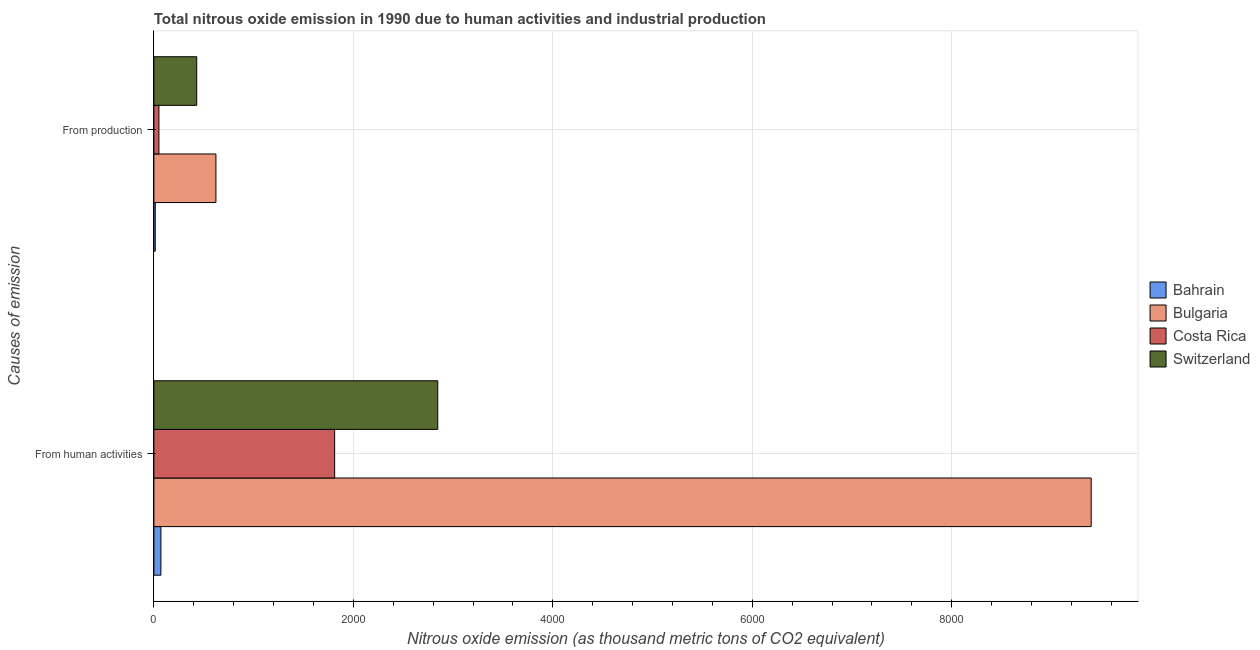Are the number of bars per tick equal to the number of legend labels?
Ensure brevity in your answer.  Yes. How many bars are there on the 1st tick from the bottom?
Your response must be concise. 4. What is the label of the 2nd group of bars from the top?
Offer a terse response. From human activities. What is the amount of emissions from human activities in Bulgaria?
Keep it short and to the point. 9398. Across all countries, what is the maximum amount of emissions generated from industries?
Your answer should be very brief. 622. Across all countries, what is the minimum amount of emissions from human activities?
Provide a short and direct response. 70.2. In which country was the amount of emissions generated from industries maximum?
Your answer should be compact. Bulgaria. In which country was the amount of emissions generated from industries minimum?
Offer a terse response. Bahrain. What is the total amount of emissions generated from industries in the graph?
Your response must be concise. 1115.8. What is the difference between the amount of emissions generated from industries in Switzerland and that in Costa Rica?
Your answer should be very brief. 379.1. What is the difference between the amount of emissions generated from industries in Switzerland and the amount of emissions from human activities in Bulgaria?
Ensure brevity in your answer.  -8968.4. What is the average amount of emissions generated from industries per country?
Keep it short and to the point. 278.95. What is the difference between the amount of emissions generated from industries and amount of emissions from human activities in Bulgaria?
Offer a terse response. -8776. What is the ratio of the amount of emissions from human activities in Bahrain to that in Bulgaria?
Ensure brevity in your answer.  0.01. How many bars are there?
Provide a succinct answer. 8. Are all the bars in the graph horizontal?
Keep it short and to the point. Yes. How many countries are there in the graph?
Make the answer very short. 4. What is the difference between two consecutive major ticks on the X-axis?
Make the answer very short. 2000. Are the values on the major ticks of X-axis written in scientific E-notation?
Give a very brief answer. No. Where does the legend appear in the graph?
Make the answer very short. Center right. How many legend labels are there?
Your answer should be compact. 4. What is the title of the graph?
Offer a very short reply. Total nitrous oxide emission in 1990 due to human activities and industrial production. What is the label or title of the X-axis?
Make the answer very short. Nitrous oxide emission (as thousand metric tons of CO2 equivalent). What is the label or title of the Y-axis?
Provide a succinct answer. Causes of emission. What is the Nitrous oxide emission (as thousand metric tons of CO2 equivalent) of Bahrain in From human activities?
Ensure brevity in your answer.  70.2. What is the Nitrous oxide emission (as thousand metric tons of CO2 equivalent) of Bulgaria in From human activities?
Provide a short and direct response. 9398. What is the Nitrous oxide emission (as thousand metric tons of CO2 equivalent) in Costa Rica in From human activities?
Make the answer very short. 1812.5. What is the Nitrous oxide emission (as thousand metric tons of CO2 equivalent) of Switzerland in From human activities?
Offer a very short reply. 2846.4. What is the Nitrous oxide emission (as thousand metric tons of CO2 equivalent) of Bahrain in From production?
Ensure brevity in your answer.  13.7. What is the Nitrous oxide emission (as thousand metric tons of CO2 equivalent) in Bulgaria in From production?
Give a very brief answer. 622. What is the Nitrous oxide emission (as thousand metric tons of CO2 equivalent) of Costa Rica in From production?
Make the answer very short. 50.5. What is the Nitrous oxide emission (as thousand metric tons of CO2 equivalent) of Switzerland in From production?
Give a very brief answer. 429.6. Across all Causes of emission, what is the maximum Nitrous oxide emission (as thousand metric tons of CO2 equivalent) in Bahrain?
Provide a short and direct response. 70.2. Across all Causes of emission, what is the maximum Nitrous oxide emission (as thousand metric tons of CO2 equivalent) of Bulgaria?
Your answer should be very brief. 9398. Across all Causes of emission, what is the maximum Nitrous oxide emission (as thousand metric tons of CO2 equivalent) in Costa Rica?
Provide a short and direct response. 1812.5. Across all Causes of emission, what is the maximum Nitrous oxide emission (as thousand metric tons of CO2 equivalent) in Switzerland?
Make the answer very short. 2846.4. Across all Causes of emission, what is the minimum Nitrous oxide emission (as thousand metric tons of CO2 equivalent) in Bulgaria?
Your answer should be very brief. 622. Across all Causes of emission, what is the minimum Nitrous oxide emission (as thousand metric tons of CO2 equivalent) of Costa Rica?
Ensure brevity in your answer.  50.5. Across all Causes of emission, what is the minimum Nitrous oxide emission (as thousand metric tons of CO2 equivalent) of Switzerland?
Provide a succinct answer. 429.6. What is the total Nitrous oxide emission (as thousand metric tons of CO2 equivalent) of Bahrain in the graph?
Ensure brevity in your answer.  83.9. What is the total Nitrous oxide emission (as thousand metric tons of CO2 equivalent) in Bulgaria in the graph?
Provide a succinct answer. 1.00e+04. What is the total Nitrous oxide emission (as thousand metric tons of CO2 equivalent) in Costa Rica in the graph?
Ensure brevity in your answer.  1863. What is the total Nitrous oxide emission (as thousand metric tons of CO2 equivalent) of Switzerland in the graph?
Your answer should be compact. 3276. What is the difference between the Nitrous oxide emission (as thousand metric tons of CO2 equivalent) of Bahrain in From human activities and that in From production?
Make the answer very short. 56.5. What is the difference between the Nitrous oxide emission (as thousand metric tons of CO2 equivalent) of Bulgaria in From human activities and that in From production?
Offer a very short reply. 8776. What is the difference between the Nitrous oxide emission (as thousand metric tons of CO2 equivalent) of Costa Rica in From human activities and that in From production?
Ensure brevity in your answer.  1762. What is the difference between the Nitrous oxide emission (as thousand metric tons of CO2 equivalent) in Switzerland in From human activities and that in From production?
Keep it short and to the point. 2416.8. What is the difference between the Nitrous oxide emission (as thousand metric tons of CO2 equivalent) in Bahrain in From human activities and the Nitrous oxide emission (as thousand metric tons of CO2 equivalent) in Bulgaria in From production?
Offer a very short reply. -551.8. What is the difference between the Nitrous oxide emission (as thousand metric tons of CO2 equivalent) in Bahrain in From human activities and the Nitrous oxide emission (as thousand metric tons of CO2 equivalent) in Switzerland in From production?
Make the answer very short. -359.4. What is the difference between the Nitrous oxide emission (as thousand metric tons of CO2 equivalent) in Bulgaria in From human activities and the Nitrous oxide emission (as thousand metric tons of CO2 equivalent) in Costa Rica in From production?
Make the answer very short. 9347.5. What is the difference between the Nitrous oxide emission (as thousand metric tons of CO2 equivalent) in Bulgaria in From human activities and the Nitrous oxide emission (as thousand metric tons of CO2 equivalent) in Switzerland in From production?
Give a very brief answer. 8968.4. What is the difference between the Nitrous oxide emission (as thousand metric tons of CO2 equivalent) of Costa Rica in From human activities and the Nitrous oxide emission (as thousand metric tons of CO2 equivalent) of Switzerland in From production?
Make the answer very short. 1382.9. What is the average Nitrous oxide emission (as thousand metric tons of CO2 equivalent) of Bahrain per Causes of emission?
Your answer should be compact. 41.95. What is the average Nitrous oxide emission (as thousand metric tons of CO2 equivalent) in Bulgaria per Causes of emission?
Make the answer very short. 5010. What is the average Nitrous oxide emission (as thousand metric tons of CO2 equivalent) in Costa Rica per Causes of emission?
Your answer should be compact. 931.5. What is the average Nitrous oxide emission (as thousand metric tons of CO2 equivalent) of Switzerland per Causes of emission?
Give a very brief answer. 1638. What is the difference between the Nitrous oxide emission (as thousand metric tons of CO2 equivalent) of Bahrain and Nitrous oxide emission (as thousand metric tons of CO2 equivalent) of Bulgaria in From human activities?
Give a very brief answer. -9327.8. What is the difference between the Nitrous oxide emission (as thousand metric tons of CO2 equivalent) of Bahrain and Nitrous oxide emission (as thousand metric tons of CO2 equivalent) of Costa Rica in From human activities?
Give a very brief answer. -1742.3. What is the difference between the Nitrous oxide emission (as thousand metric tons of CO2 equivalent) of Bahrain and Nitrous oxide emission (as thousand metric tons of CO2 equivalent) of Switzerland in From human activities?
Keep it short and to the point. -2776.2. What is the difference between the Nitrous oxide emission (as thousand metric tons of CO2 equivalent) in Bulgaria and Nitrous oxide emission (as thousand metric tons of CO2 equivalent) in Costa Rica in From human activities?
Give a very brief answer. 7585.5. What is the difference between the Nitrous oxide emission (as thousand metric tons of CO2 equivalent) of Bulgaria and Nitrous oxide emission (as thousand metric tons of CO2 equivalent) of Switzerland in From human activities?
Your response must be concise. 6551.6. What is the difference between the Nitrous oxide emission (as thousand metric tons of CO2 equivalent) of Costa Rica and Nitrous oxide emission (as thousand metric tons of CO2 equivalent) of Switzerland in From human activities?
Your response must be concise. -1033.9. What is the difference between the Nitrous oxide emission (as thousand metric tons of CO2 equivalent) of Bahrain and Nitrous oxide emission (as thousand metric tons of CO2 equivalent) of Bulgaria in From production?
Ensure brevity in your answer.  -608.3. What is the difference between the Nitrous oxide emission (as thousand metric tons of CO2 equivalent) of Bahrain and Nitrous oxide emission (as thousand metric tons of CO2 equivalent) of Costa Rica in From production?
Offer a very short reply. -36.8. What is the difference between the Nitrous oxide emission (as thousand metric tons of CO2 equivalent) of Bahrain and Nitrous oxide emission (as thousand metric tons of CO2 equivalent) of Switzerland in From production?
Keep it short and to the point. -415.9. What is the difference between the Nitrous oxide emission (as thousand metric tons of CO2 equivalent) in Bulgaria and Nitrous oxide emission (as thousand metric tons of CO2 equivalent) in Costa Rica in From production?
Make the answer very short. 571.5. What is the difference between the Nitrous oxide emission (as thousand metric tons of CO2 equivalent) of Bulgaria and Nitrous oxide emission (as thousand metric tons of CO2 equivalent) of Switzerland in From production?
Keep it short and to the point. 192.4. What is the difference between the Nitrous oxide emission (as thousand metric tons of CO2 equivalent) of Costa Rica and Nitrous oxide emission (as thousand metric tons of CO2 equivalent) of Switzerland in From production?
Your response must be concise. -379.1. What is the ratio of the Nitrous oxide emission (as thousand metric tons of CO2 equivalent) of Bahrain in From human activities to that in From production?
Your response must be concise. 5.12. What is the ratio of the Nitrous oxide emission (as thousand metric tons of CO2 equivalent) of Bulgaria in From human activities to that in From production?
Your answer should be compact. 15.11. What is the ratio of the Nitrous oxide emission (as thousand metric tons of CO2 equivalent) of Costa Rica in From human activities to that in From production?
Give a very brief answer. 35.89. What is the ratio of the Nitrous oxide emission (as thousand metric tons of CO2 equivalent) of Switzerland in From human activities to that in From production?
Your response must be concise. 6.63. What is the difference between the highest and the second highest Nitrous oxide emission (as thousand metric tons of CO2 equivalent) in Bahrain?
Your response must be concise. 56.5. What is the difference between the highest and the second highest Nitrous oxide emission (as thousand metric tons of CO2 equivalent) in Bulgaria?
Make the answer very short. 8776. What is the difference between the highest and the second highest Nitrous oxide emission (as thousand metric tons of CO2 equivalent) in Costa Rica?
Provide a short and direct response. 1762. What is the difference between the highest and the second highest Nitrous oxide emission (as thousand metric tons of CO2 equivalent) of Switzerland?
Ensure brevity in your answer.  2416.8. What is the difference between the highest and the lowest Nitrous oxide emission (as thousand metric tons of CO2 equivalent) of Bahrain?
Provide a short and direct response. 56.5. What is the difference between the highest and the lowest Nitrous oxide emission (as thousand metric tons of CO2 equivalent) of Bulgaria?
Provide a succinct answer. 8776. What is the difference between the highest and the lowest Nitrous oxide emission (as thousand metric tons of CO2 equivalent) of Costa Rica?
Provide a short and direct response. 1762. What is the difference between the highest and the lowest Nitrous oxide emission (as thousand metric tons of CO2 equivalent) of Switzerland?
Your answer should be compact. 2416.8. 